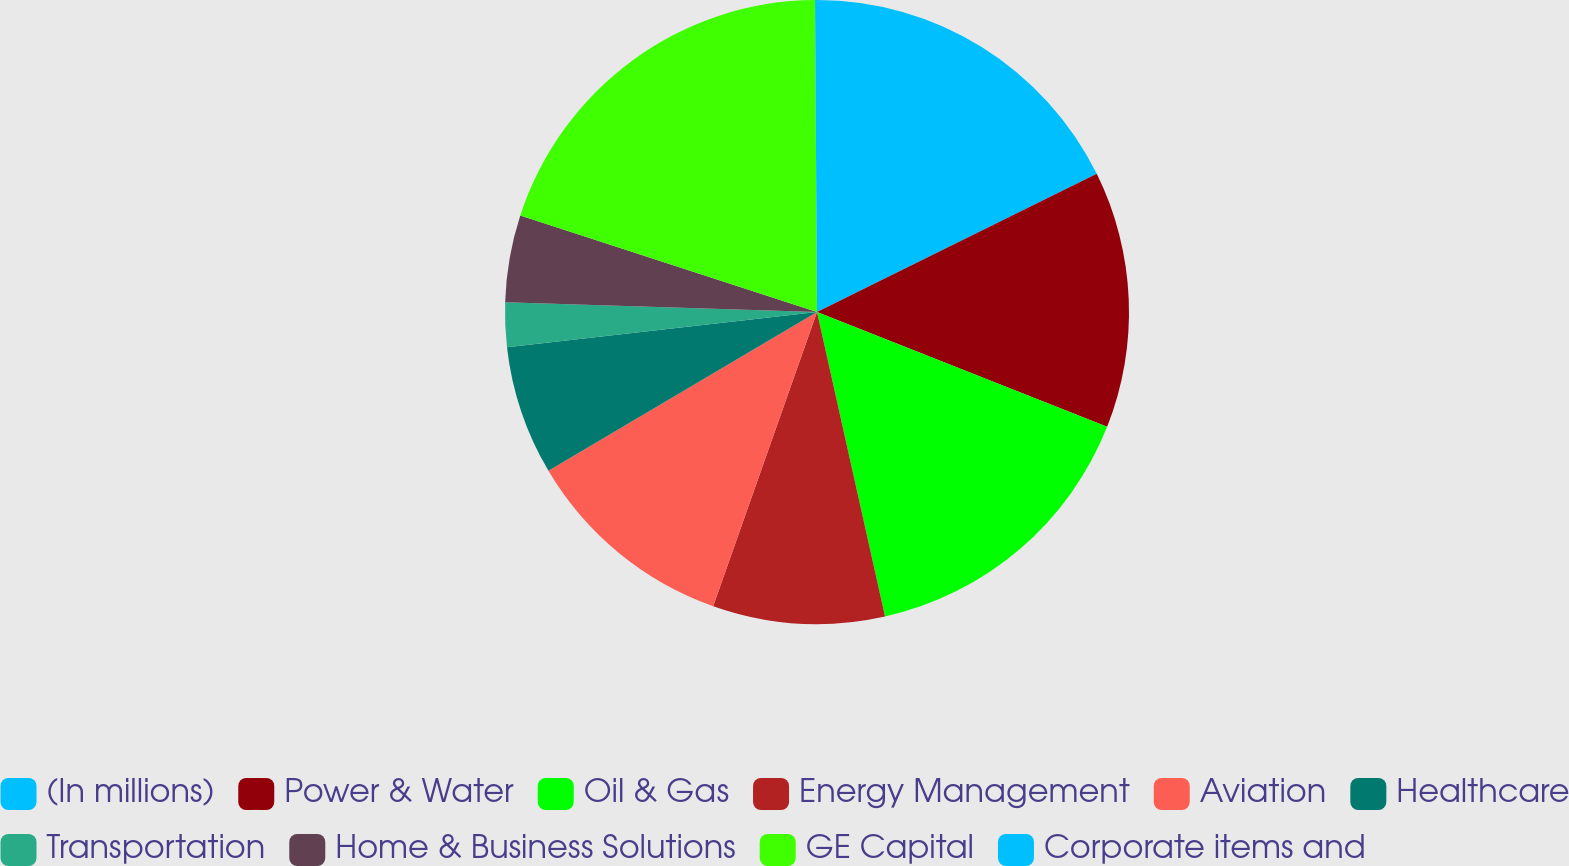<chart> <loc_0><loc_0><loc_500><loc_500><pie_chart><fcel>(In millions)<fcel>Power & Water<fcel>Oil & Gas<fcel>Energy Management<fcel>Aviation<fcel>Healthcare<fcel>Transportation<fcel>Home & Business Solutions<fcel>GE Capital<fcel>Corporate items and<nl><fcel>17.7%<fcel>13.3%<fcel>15.5%<fcel>8.9%<fcel>11.1%<fcel>6.7%<fcel>2.3%<fcel>4.5%<fcel>19.9%<fcel>0.1%<nl></chart> 